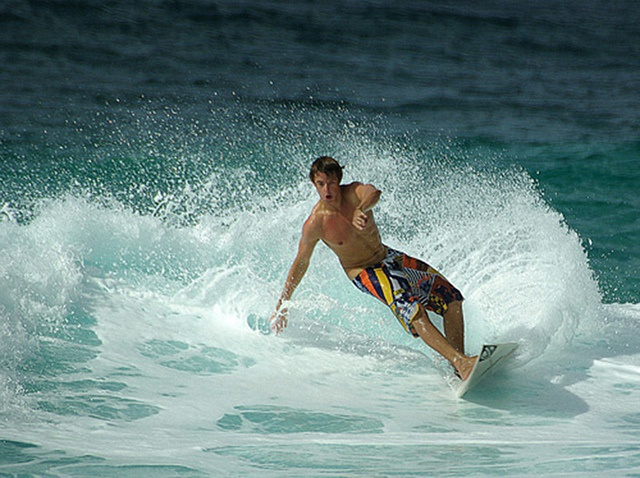Describe the objects in this image and their specific colors. I can see people in black, maroon, and gray tones and surfboard in black, teal, gray, and darkgray tones in this image. 